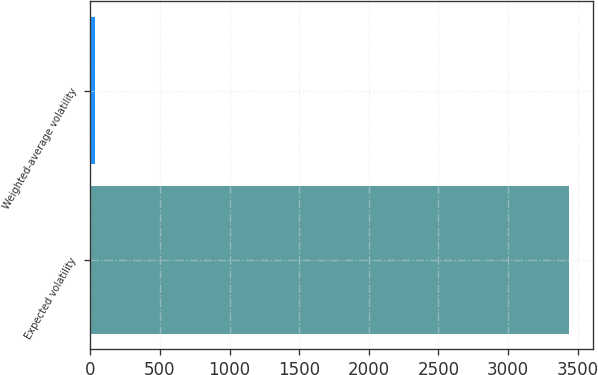<chart> <loc_0><loc_0><loc_500><loc_500><bar_chart><fcel>Expected volatility<fcel>Weighted-average volatility<nl><fcel>3438<fcel>36<nl></chart> 